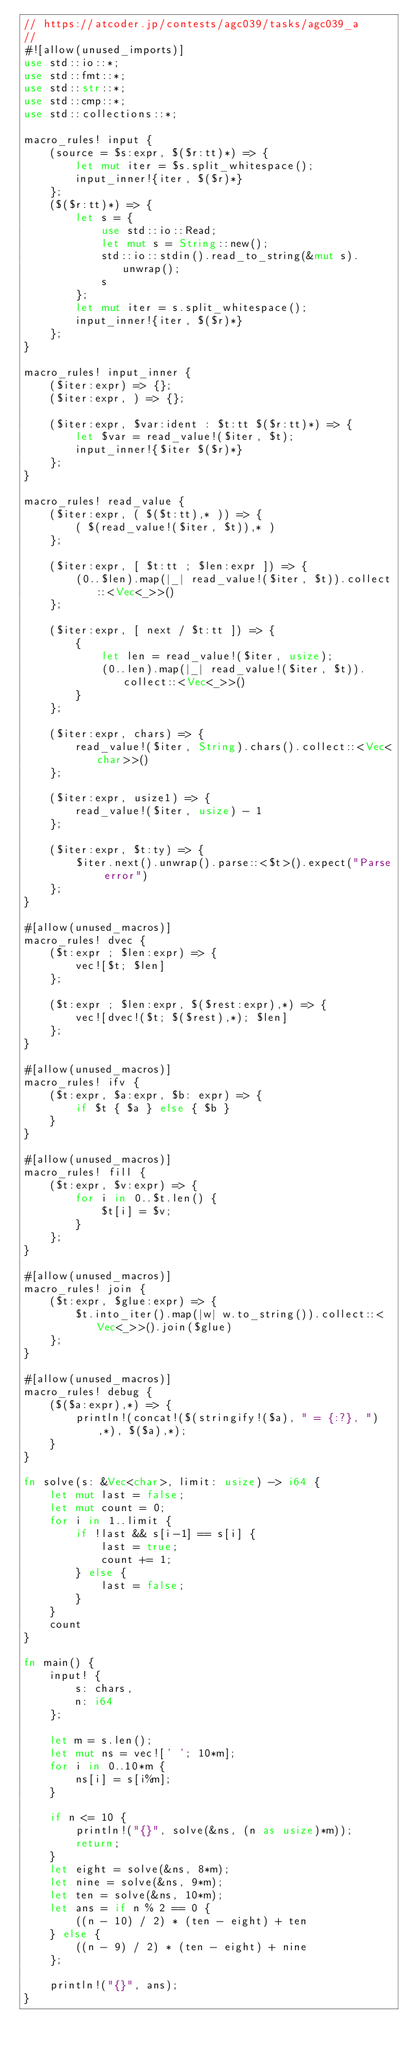<code> <loc_0><loc_0><loc_500><loc_500><_Rust_>// https://atcoder.jp/contests/agc039/tasks/agc039_a
//
#![allow(unused_imports)]
use std::io::*;
use std::fmt::*;
use std::str::*;
use std::cmp::*;
use std::collections::*;

macro_rules! input {
    (source = $s:expr, $($r:tt)*) => {
        let mut iter = $s.split_whitespace();
        input_inner!{iter, $($r)*}
    };
    ($($r:tt)*) => {
        let s = {
            use std::io::Read;
            let mut s = String::new();
            std::io::stdin().read_to_string(&mut s).unwrap();
            s
        };
        let mut iter = s.split_whitespace();
        input_inner!{iter, $($r)*}
    };
}

macro_rules! input_inner {
    ($iter:expr) => {};
    ($iter:expr, ) => {};

    ($iter:expr, $var:ident : $t:tt $($r:tt)*) => {
        let $var = read_value!($iter, $t);
        input_inner!{$iter $($r)*}
    };
}

macro_rules! read_value {
    ($iter:expr, ( $($t:tt),* )) => {
        ( $(read_value!($iter, $t)),* )
    };

    ($iter:expr, [ $t:tt ; $len:expr ]) => {
        (0..$len).map(|_| read_value!($iter, $t)).collect::<Vec<_>>()
    };

    ($iter:expr, [ next / $t:tt ]) => {
        {
            let len = read_value!($iter, usize);
            (0..len).map(|_| read_value!($iter, $t)).collect::<Vec<_>>()
        }
    };

    ($iter:expr, chars) => {
        read_value!($iter, String).chars().collect::<Vec<char>>()
    };

    ($iter:expr, usize1) => {
        read_value!($iter, usize) - 1
    };

    ($iter:expr, $t:ty) => {
        $iter.next().unwrap().parse::<$t>().expect("Parse error")
    };
}

#[allow(unused_macros)]
macro_rules! dvec {
    ($t:expr ; $len:expr) => {
        vec![$t; $len]
    };

    ($t:expr ; $len:expr, $($rest:expr),*) => {
        vec![dvec!($t; $($rest),*); $len]
    };
}

#[allow(unused_macros)]
macro_rules! ifv {
    ($t:expr, $a:expr, $b: expr) => {
        if $t { $a } else { $b }
    }
}

#[allow(unused_macros)]
macro_rules! fill {
    ($t:expr, $v:expr) => {
        for i in 0..$t.len() {
            $t[i] = $v;
        }
    };
}

#[allow(unused_macros)]
macro_rules! join {
    ($t:expr, $glue:expr) => {
        $t.into_iter().map(|w| w.to_string()).collect::<Vec<_>>().join($glue)
    };
}

#[allow(unused_macros)]
macro_rules! debug {
    ($($a:expr),*) => {
        println!(concat!($(stringify!($a), " = {:?}, "),*), $($a),*);
    }
}

fn solve(s: &Vec<char>, limit: usize) -> i64 {
    let mut last = false;
    let mut count = 0;
    for i in 1..limit {
        if !last && s[i-1] == s[i] {
            last = true;
            count += 1;
        } else {
            last = false;
        }
    }
    count
}

fn main() {
    input! {
        s: chars,
        n: i64
    };

    let m = s.len();
    let mut ns = vec![' '; 10*m];
    for i in 0..10*m {
        ns[i] = s[i%m];
    }

    if n <= 10 {
        println!("{}", solve(&ns, (n as usize)*m));
        return;
    }
    let eight = solve(&ns, 8*m);
    let nine = solve(&ns, 9*m);
    let ten = solve(&ns, 10*m);
    let ans = if n % 2 == 0 {
        ((n - 10) / 2) * (ten - eight) + ten
    } else {
        ((n - 9) / 2) * (ten - eight) + nine
    };

    println!("{}", ans);
}
</code> 